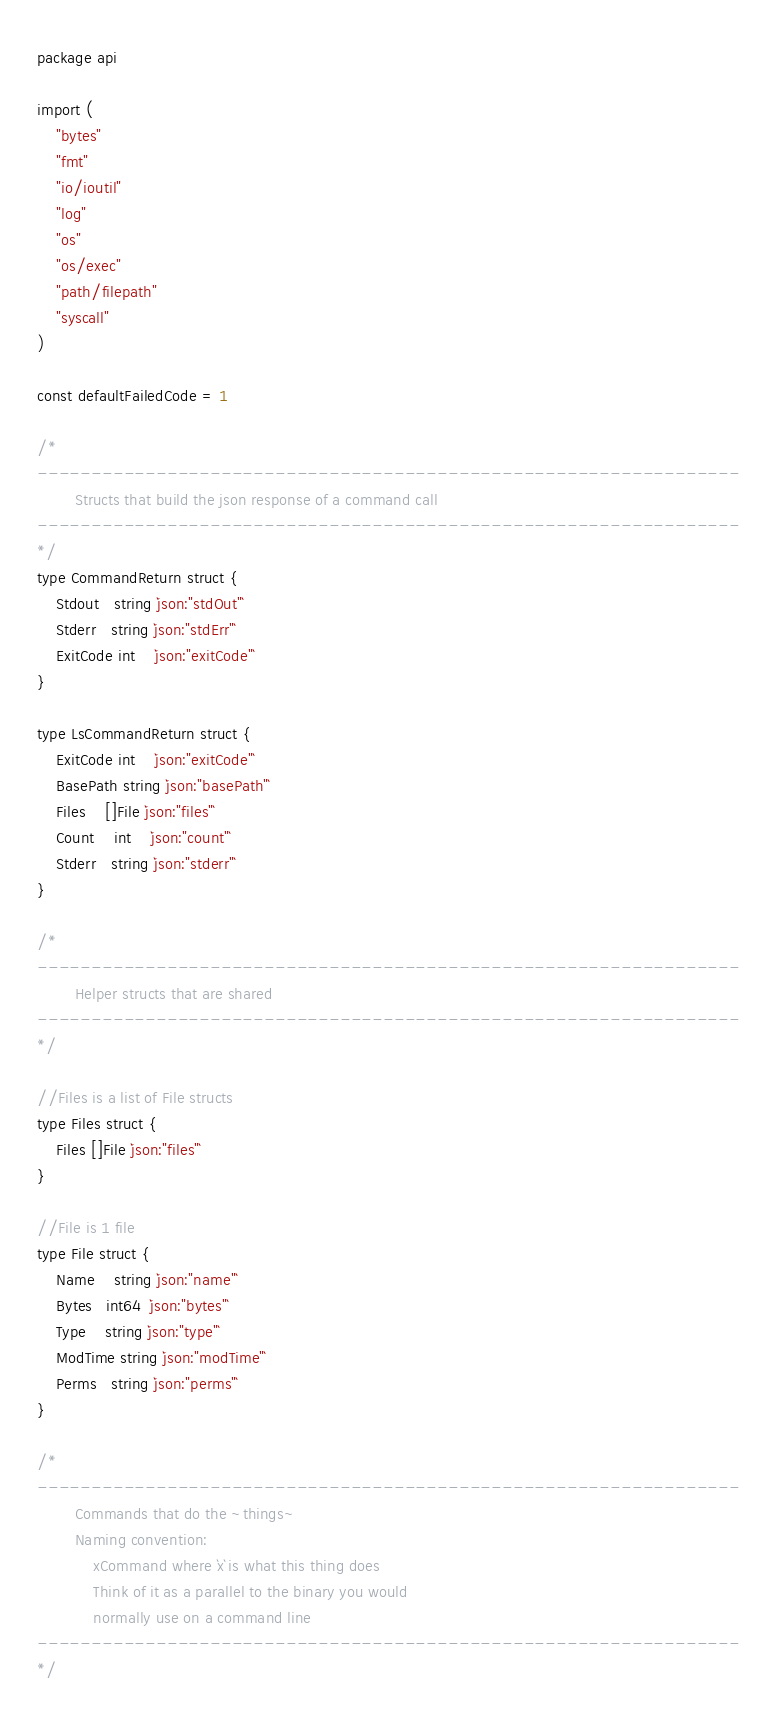<code> <loc_0><loc_0><loc_500><loc_500><_Go_>package api

import (
	"bytes"
	"fmt"
	"io/ioutil"
	"log"
	"os"
	"os/exec"
	"path/filepath"
	"syscall"
)

const defaultFailedCode = 1

/*
-----------------------------------------------------------------
		Structs that build the json response of a command call
-----------------------------------------------------------------
*/
type CommandReturn struct {
	Stdout   string `json:"stdOut"`
	Stderr   string `json:"stdErr"`
	ExitCode int    `json:"exitCode"`
}

type LsCommandReturn struct {
	ExitCode int    `json:"exitCode"`
	BasePath string `json:"basePath"`
	Files    []File `json:"files"`
	Count    int    `json:"count"`
	Stderr   string `json:"stderr"`
}

/*
-----------------------------------------------------------------
		Helper structs that are shared
-----------------------------------------------------------------
*/

//Files is a list of File structs
type Files struct {
	Files []File `json:"files"`
}

//File is 1 file
type File struct {
	Name    string `json:"name"`
	Bytes   int64  `json:"bytes"`
	Type    string `json:"type"`
	ModTime string `json:"modTime"`
	Perms   string `json:"perms"`
}

/*
-----------------------------------------------------------------
        Commands that do the ~things~
        Naming convention:
            xCommand where `x` is what this thing does
            Think of it as a parallel to the binary you would
            normally use on a command line
-----------------------------------------------------------------
*/</code> 